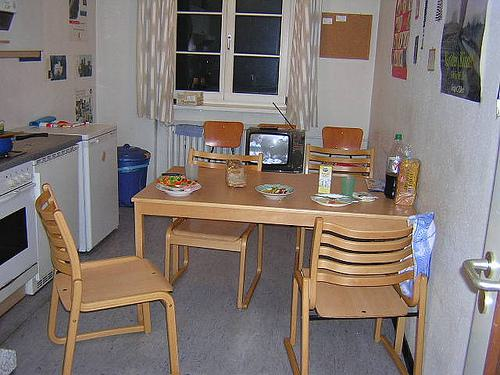Can you point out any personal items that give us a hint about who lives here? There are various personal touches in the room, such as posters on the wall and a small TV set, indicating a lived-in space with individual character, possibly belonging to someone with practical needs and a casual lifestyle. 